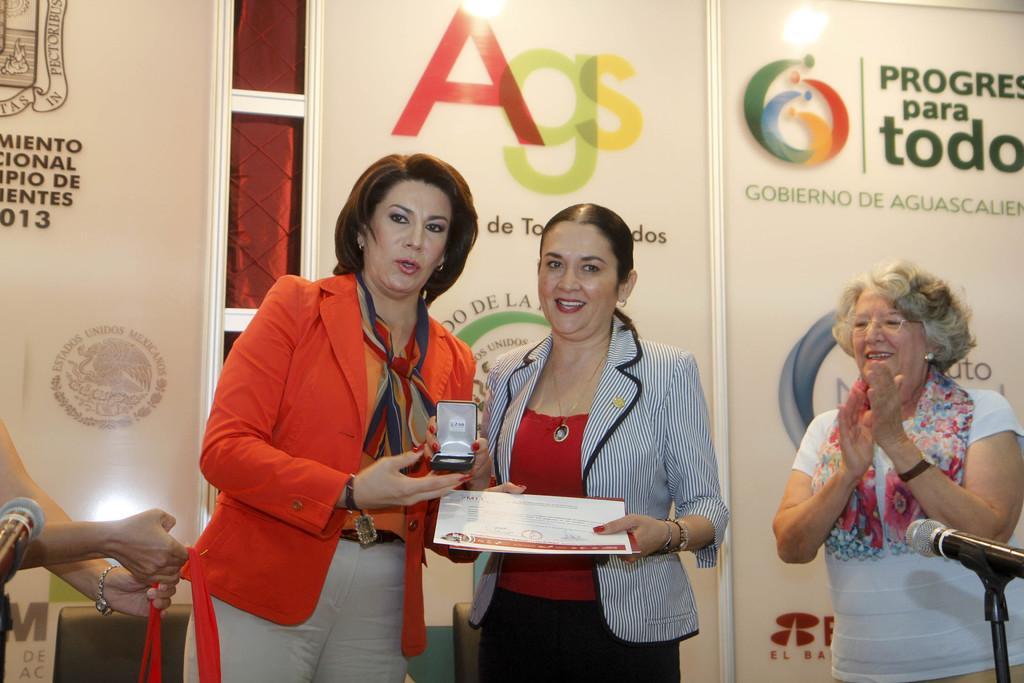Can you describe this image briefly? In this picture we can see four people where a woman clapping her hands and two women holding a certificate and a box with their hands and smiling, mics and in the background we can see posters. 